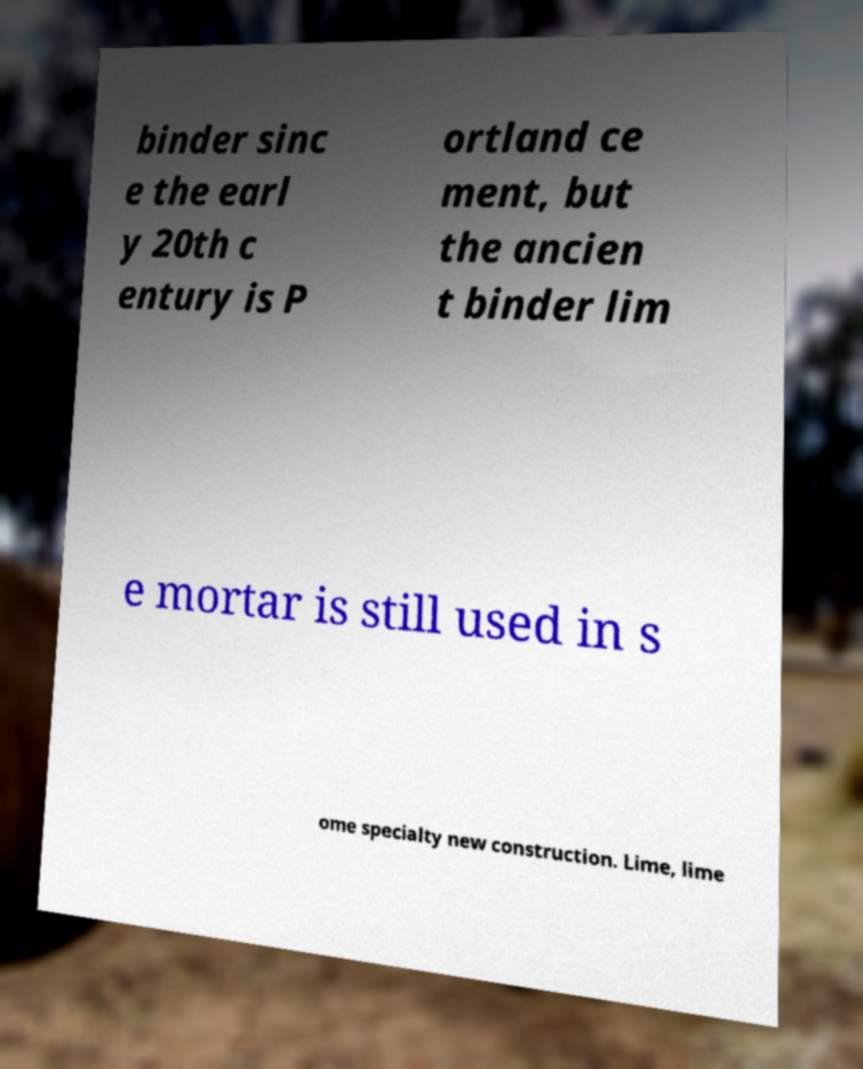Please read and relay the text visible in this image. What does it say? binder sinc e the earl y 20th c entury is P ortland ce ment, but the ancien t binder lim e mortar is still used in s ome specialty new construction. Lime, lime 